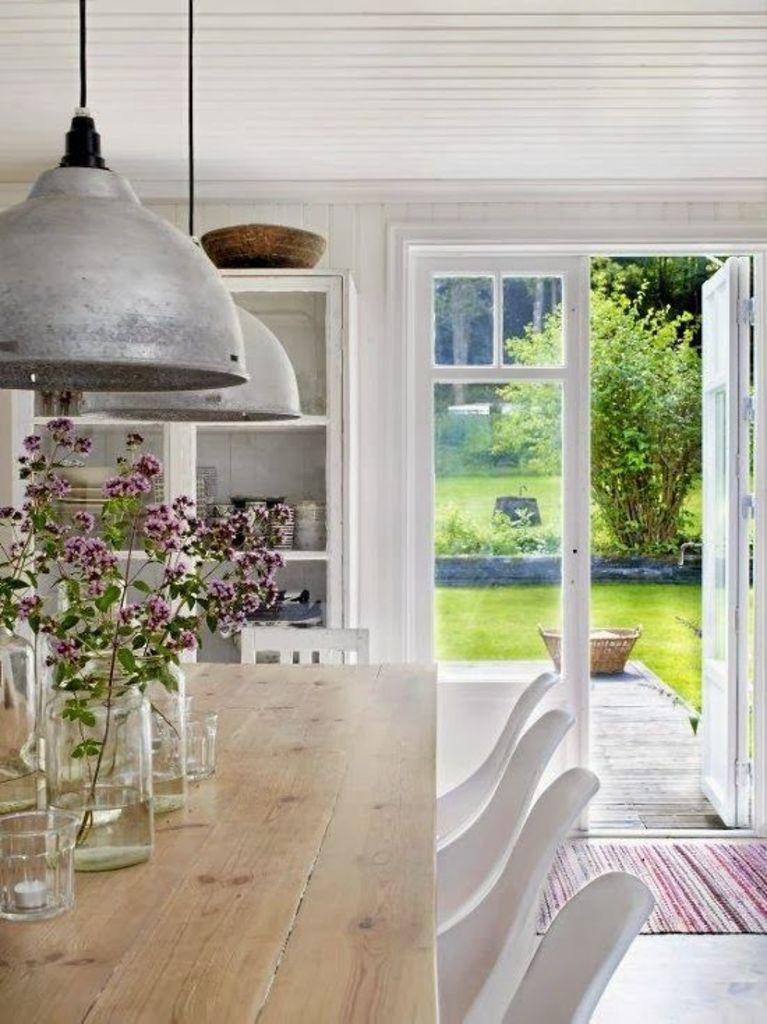Please provide a concise description of this image. In this Image I see a table on which there are glasses and there are plants in it. I can also see few chairs near the table. In the background I see a rack in which there are few things and there is a door over here and I see plants and the grass over here. 